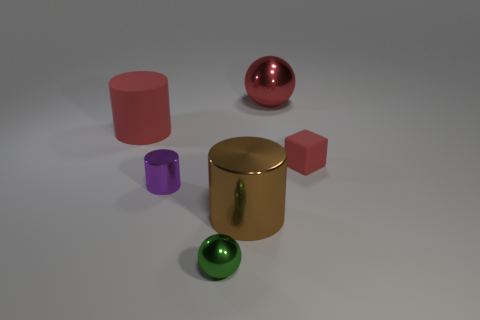Add 1 large red things. How many objects exist? 7 Subtract all blocks. How many objects are left? 5 Subtract 0 yellow balls. How many objects are left? 6 Subtract all green things. Subtract all big red balls. How many objects are left? 4 Add 3 rubber cylinders. How many rubber cylinders are left? 4 Add 3 tiny cylinders. How many tiny cylinders exist? 4 